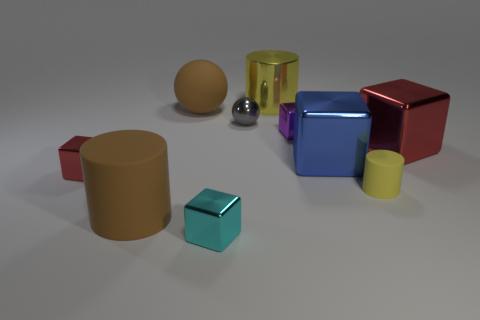Subtract all small red cubes. How many cubes are left? 4 Subtract 1 balls. How many balls are left? 1 Subtract all green cylinders. How many purple spheres are left? 0 Subtract all shiny spheres. Subtract all small red things. How many objects are left? 8 Add 8 tiny purple metal cubes. How many tiny purple metal cubes are left? 9 Add 9 metal spheres. How many metal spheres exist? 10 Subtract all red blocks. How many blocks are left? 3 Subtract 0 green blocks. How many objects are left? 10 Subtract all cylinders. How many objects are left? 7 Subtract all yellow blocks. Subtract all blue spheres. How many blocks are left? 5 